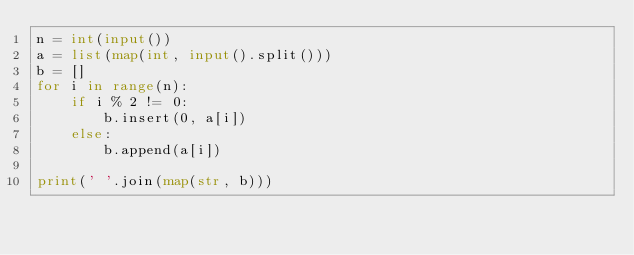<code> <loc_0><loc_0><loc_500><loc_500><_Python_>n = int(input())
a = list(map(int, input().split()))
b = []
for i in range(n):
    if i % 2 != 0:
        b.insert(0, a[i])
    else:
        b.append(a[i])

print(' '.join(map(str, b)))</code> 